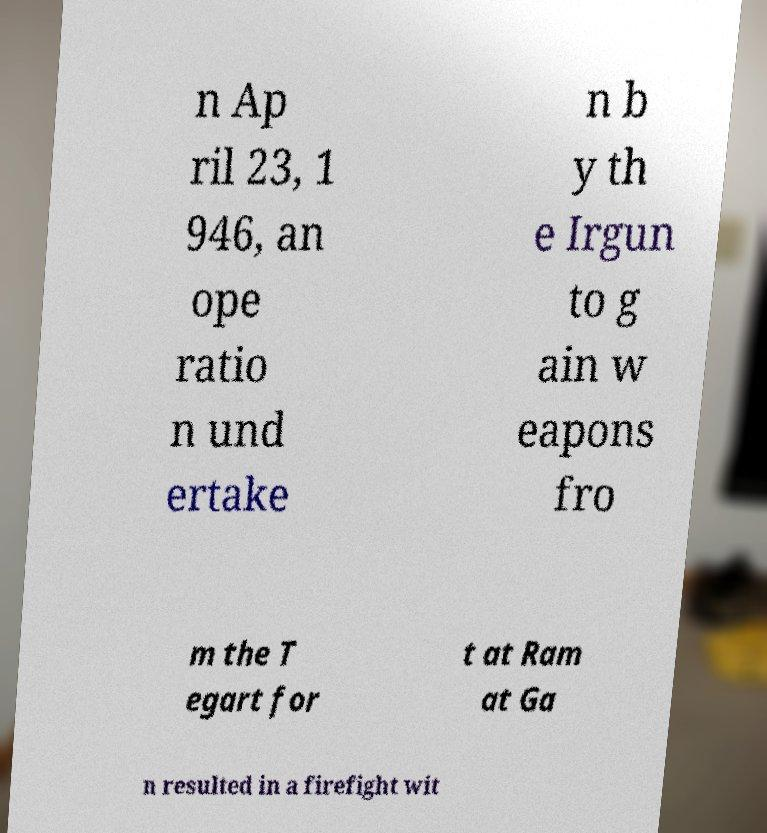For documentation purposes, I need the text within this image transcribed. Could you provide that? n Ap ril 23, 1 946, an ope ratio n und ertake n b y th e Irgun to g ain w eapons fro m the T egart for t at Ram at Ga n resulted in a firefight wit 